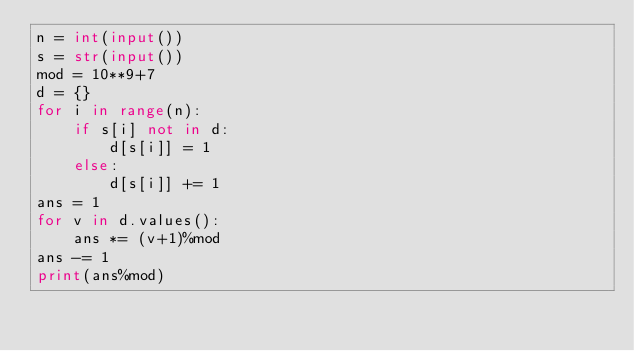<code> <loc_0><loc_0><loc_500><loc_500><_Python_>n = int(input())
s = str(input())
mod = 10**9+7
d = {}
for i in range(n):
    if s[i] not in d:
        d[s[i]] = 1
    else:
        d[s[i]] += 1
ans = 1
for v in d.values():
    ans *= (v+1)%mod
ans -= 1
print(ans%mod)</code> 